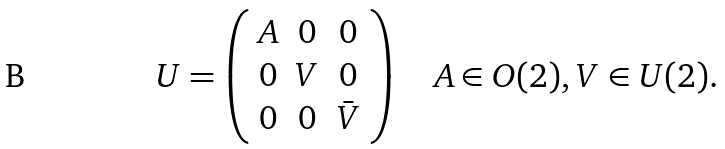Convert formula to latex. <formula><loc_0><loc_0><loc_500><loc_500>U = \left ( \begin{array} { c c c } A & 0 & 0 \\ 0 & V & 0 \\ 0 & 0 & \bar { V } \end{array} \right ) \quad A \in O ( 2 ) , V \in U ( 2 ) .</formula> 